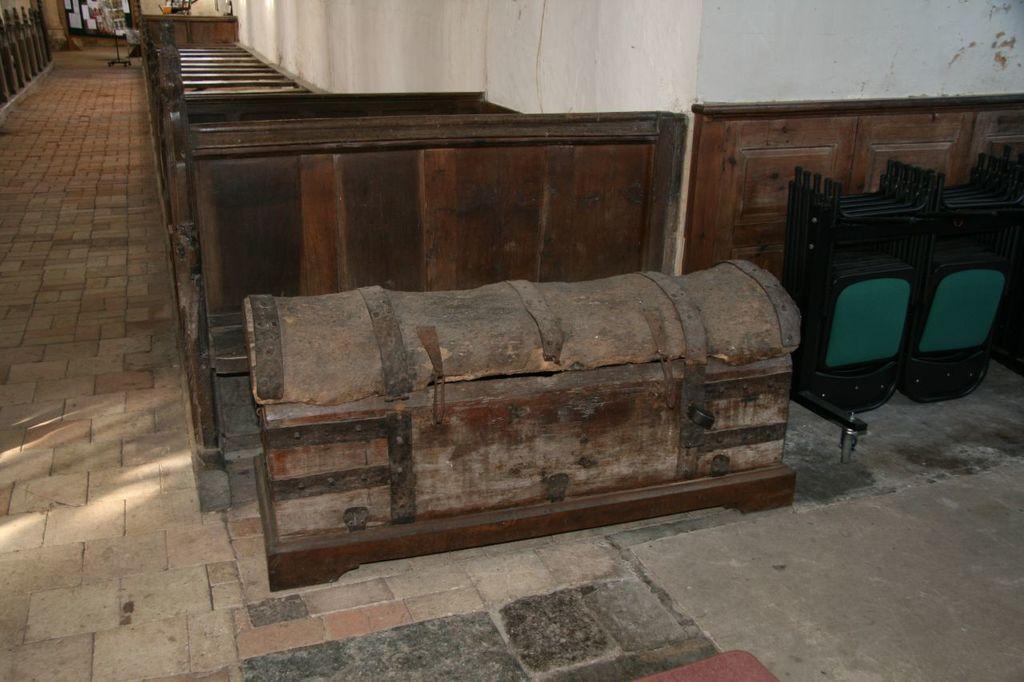Could you give a brief overview of what you see in this image? In this picture we can see the floor, here we can see a wall, box, wooden objects and some objects. 